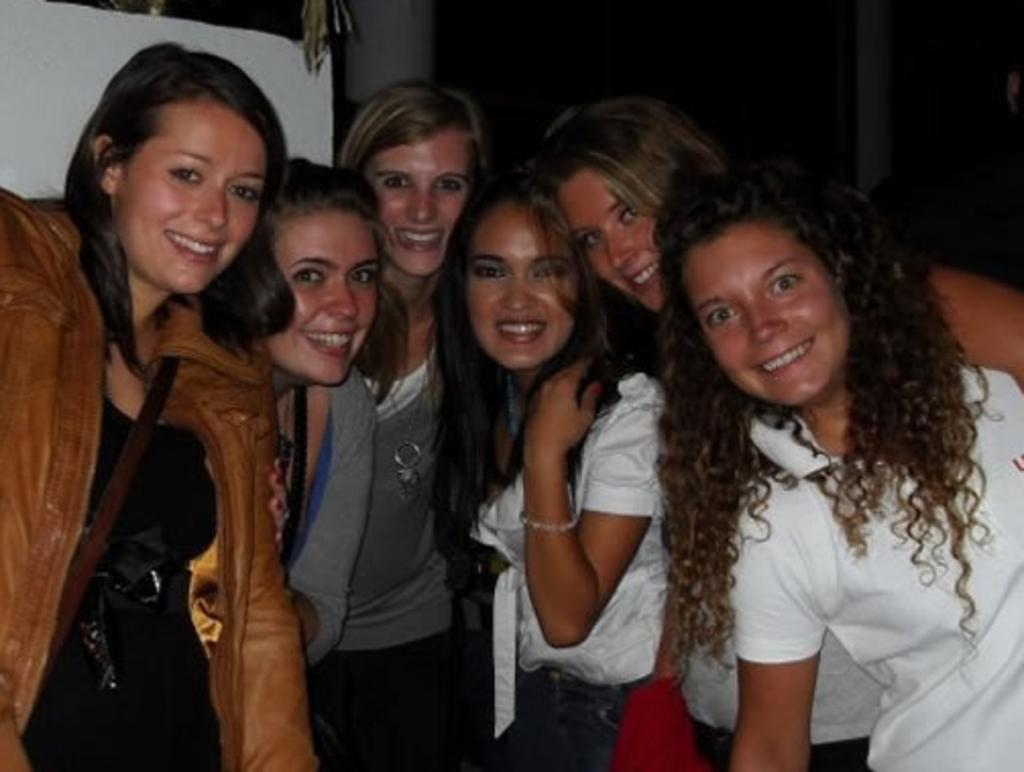What is happening in the image involving a group of people? There is a group of people in the image, and they are standing and smiling. Can you describe the mood or emotion of the people in the image? The people in the image are smiling, which suggests a positive or happy mood. What can be seen in the background of the image? There are objects in the background of the image. What type of pipe is being pulled by the people in the image? There is no pipe present in the image, and the people are not shown pulling anything. 